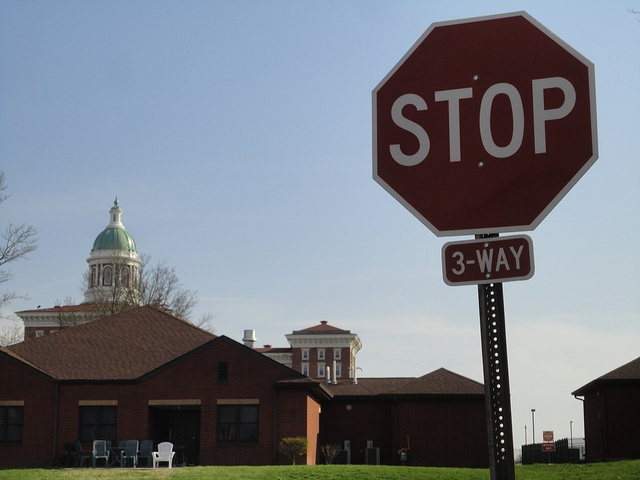Describe the objects in this image and their specific colors. I can see stop sign in gray, black, maroon, and darkgray tones, chair in gray, black, and purple tones, chair in gray, darkgray, black, and lightgray tones, chair in gray, black, and purple tones, and chair in gray, black, and purple tones in this image. 